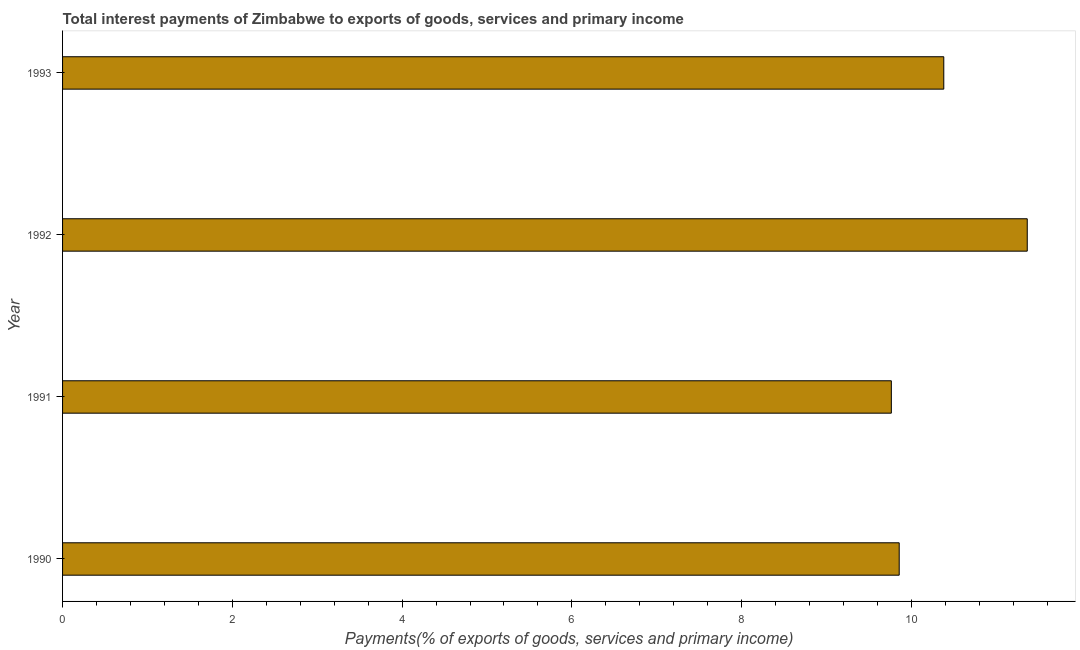Does the graph contain grids?
Your answer should be very brief. No. What is the title of the graph?
Your response must be concise. Total interest payments of Zimbabwe to exports of goods, services and primary income. What is the label or title of the X-axis?
Offer a terse response. Payments(% of exports of goods, services and primary income). What is the total interest payments on external debt in 1991?
Provide a succinct answer. 9.76. Across all years, what is the maximum total interest payments on external debt?
Your response must be concise. 11.36. Across all years, what is the minimum total interest payments on external debt?
Give a very brief answer. 9.76. What is the sum of the total interest payments on external debt?
Provide a short and direct response. 41.37. What is the difference between the total interest payments on external debt in 1992 and 1993?
Provide a short and direct response. 0.98. What is the average total interest payments on external debt per year?
Keep it short and to the point. 10.34. What is the median total interest payments on external debt?
Keep it short and to the point. 10.12. In how many years, is the total interest payments on external debt greater than 9.6 %?
Give a very brief answer. 4. Is the difference between the total interest payments on external debt in 1990 and 1991 greater than the difference between any two years?
Provide a short and direct response. No. Are all the bars in the graph horizontal?
Provide a short and direct response. Yes. How many years are there in the graph?
Ensure brevity in your answer.  4. What is the difference between two consecutive major ticks on the X-axis?
Ensure brevity in your answer.  2. Are the values on the major ticks of X-axis written in scientific E-notation?
Ensure brevity in your answer.  No. What is the Payments(% of exports of goods, services and primary income) of 1990?
Provide a short and direct response. 9.86. What is the Payments(% of exports of goods, services and primary income) of 1991?
Ensure brevity in your answer.  9.76. What is the Payments(% of exports of goods, services and primary income) in 1992?
Your response must be concise. 11.36. What is the Payments(% of exports of goods, services and primary income) in 1993?
Make the answer very short. 10.38. What is the difference between the Payments(% of exports of goods, services and primary income) in 1990 and 1991?
Give a very brief answer. 0.09. What is the difference between the Payments(% of exports of goods, services and primary income) in 1990 and 1992?
Your answer should be very brief. -1.51. What is the difference between the Payments(% of exports of goods, services and primary income) in 1990 and 1993?
Make the answer very short. -0.53. What is the difference between the Payments(% of exports of goods, services and primary income) in 1991 and 1992?
Offer a very short reply. -1.6. What is the difference between the Payments(% of exports of goods, services and primary income) in 1991 and 1993?
Keep it short and to the point. -0.62. What is the difference between the Payments(% of exports of goods, services and primary income) in 1992 and 1993?
Your answer should be very brief. 0.98. What is the ratio of the Payments(% of exports of goods, services and primary income) in 1990 to that in 1992?
Provide a short and direct response. 0.87. What is the ratio of the Payments(% of exports of goods, services and primary income) in 1990 to that in 1993?
Your answer should be very brief. 0.95. What is the ratio of the Payments(% of exports of goods, services and primary income) in 1991 to that in 1992?
Provide a succinct answer. 0.86. What is the ratio of the Payments(% of exports of goods, services and primary income) in 1992 to that in 1993?
Your response must be concise. 1.09. 